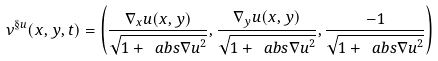Convert formula to latex. <formula><loc_0><loc_0><loc_500><loc_500>\nu ^ { \S u } ( x , y , t ) = \left ( \frac { \nabla _ { x } u ( x , y ) } { \sqrt { 1 + \ a b s { \nabla u } ^ { 2 } } } , \frac { \nabla _ { y } u ( x , y ) } { \sqrt { 1 + \ a b s { \nabla u } ^ { 2 } } } , \frac { - 1 } { \sqrt { 1 + \ a b s { \nabla u } ^ { 2 } } } \right )</formula> 